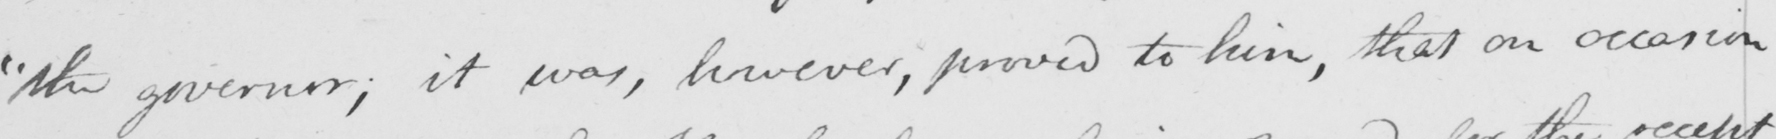Transcribe the text shown in this historical manuscript line. " the governor ; it was , however , proved to him , that on occasion 